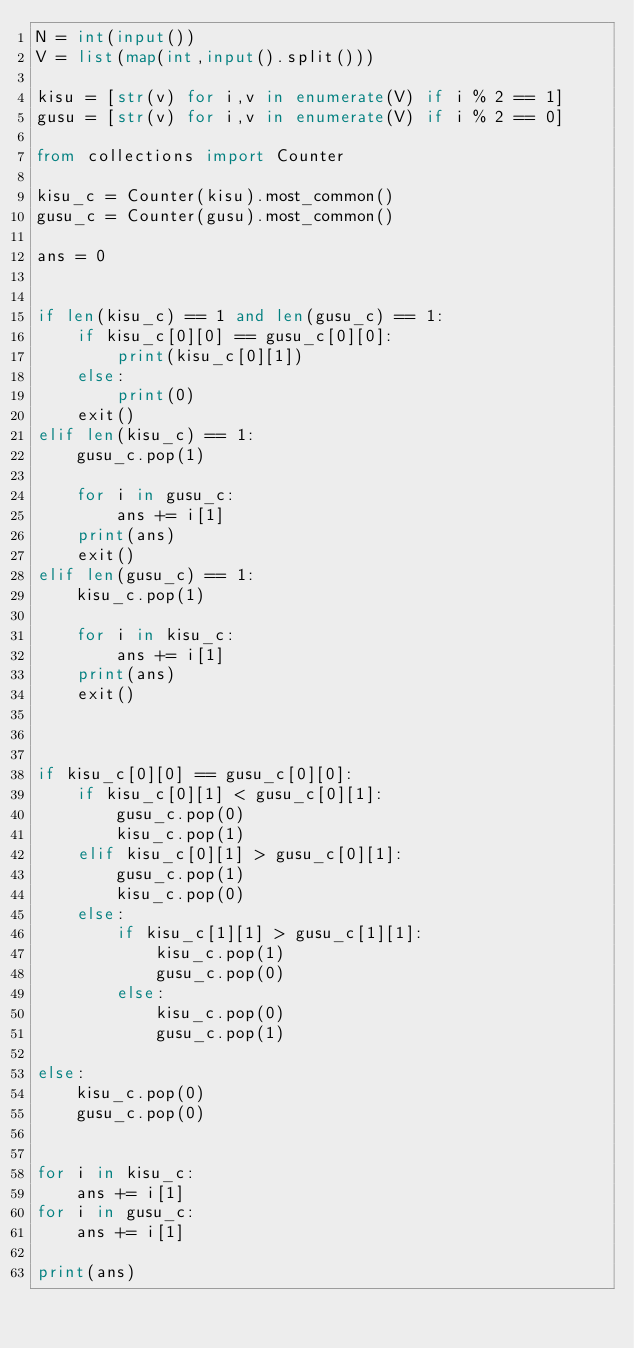Convert code to text. <code><loc_0><loc_0><loc_500><loc_500><_Python_>N = int(input())
V = list(map(int,input().split()))

kisu = [str(v) for i,v in enumerate(V) if i % 2 == 1]
gusu = [str(v) for i,v in enumerate(V) if i % 2 == 0]

from collections import Counter

kisu_c = Counter(kisu).most_common()
gusu_c = Counter(gusu).most_common()

ans = 0


if len(kisu_c) == 1 and len(gusu_c) == 1:
    if kisu_c[0][0] == gusu_c[0][0]:
        print(kisu_c[0][1])
    else:
        print(0)
    exit()
elif len(kisu_c) == 1:
    gusu_c.pop(1)

    for i in gusu_c:
        ans += i[1]
    print(ans)
    exit()
elif len(gusu_c) == 1:
    kisu_c.pop(1)

    for i in kisu_c:
        ans += i[1]
    print(ans)
    exit()



if kisu_c[0][0] == gusu_c[0][0]:
    if kisu_c[0][1] < gusu_c[0][1]:
        gusu_c.pop(0)
        kisu_c.pop(1)
    elif kisu_c[0][1] > gusu_c[0][1]:
        gusu_c.pop(1)
        kisu_c.pop(0)
    else:
        if kisu_c[1][1] > gusu_c[1][1]:
            kisu_c.pop(1)
            gusu_c.pop(0)
        else:
            kisu_c.pop(0)
            gusu_c.pop(1)

else:
    kisu_c.pop(0)
    gusu_c.pop(0)


for i in kisu_c:
    ans += i[1]
for i in gusu_c:
    ans += i[1]

print(ans)</code> 